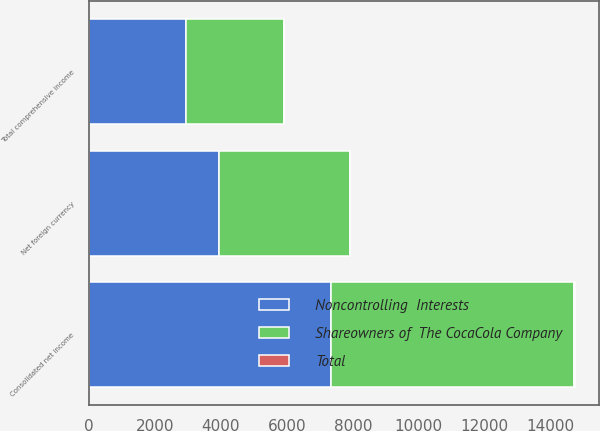Convert chart. <chart><loc_0><loc_0><loc_500><loc_500><stacked_bar_chart><ecel><fcel>Consolidated net income<fcel>Net foreign currency<fcel>Total comprehensive income<nl><fcel>Noncontrolling  Interests<fcel>7351<fcel>3941<fcel>2954<nl><fcel>Total<fcel>15<fcel>18<fcel>3<nl><fcel>Shareowners of  The CocaCola Company<fcel>7366<fcel>3959<fcel>2951<nl></chart> 